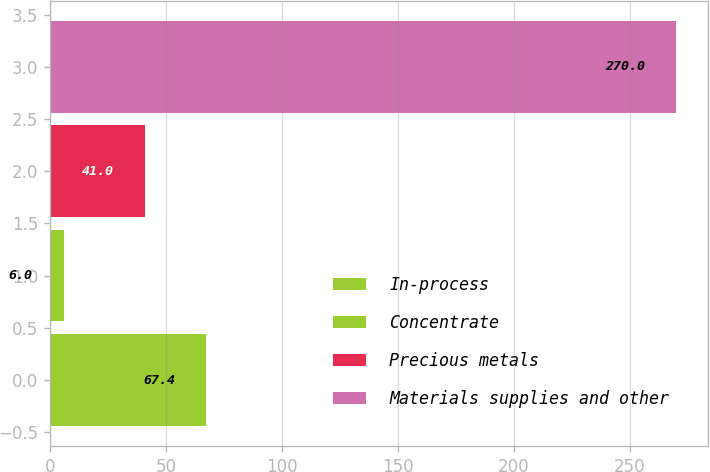Convert chart to OTSL. <chart><loc_0><loc_0><loc_500><loc_500><bar_chart><fcel>In-process<fcel>Concentrate<fcel>Precious metals<fcel>Materials supplies and other<nl><fcel>67.4<fcel>6<fcel>41<fcel>270<nl></chart> 